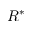<formula> <loc_0><loc_0><loc_500><loc_500>R ^ { * }</formula> 